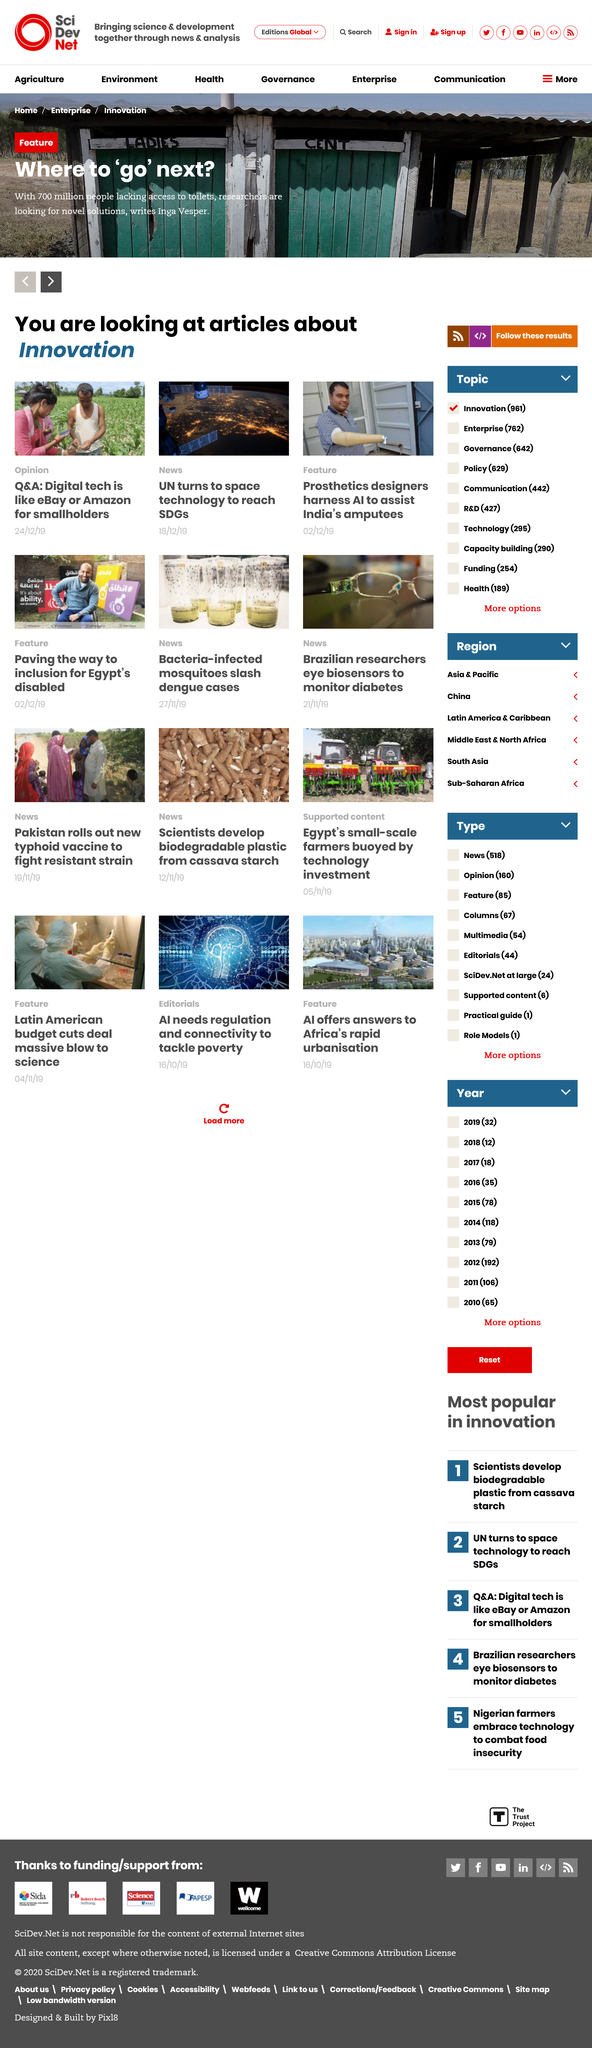Outline some significant characteristics in this image. Prosthetics designers are utilizing AI to aid India's amputees by creating advanced and more functional prosthetic limbs. The United Nations is utilizing space technology to assist in achieving the Sustainable Development Goals. It is estimated that 700 million people lack access to toilets, demonstrating a significant global sanitation challenge. 